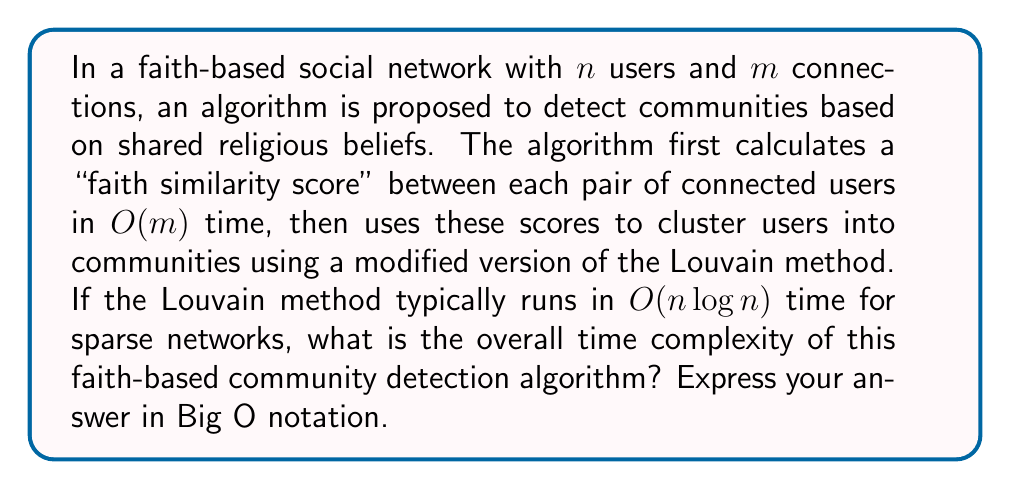Teach me how to tackle this problem. To analyze the time complexity of this algorithm, we need to consider its two main steps:

1. Calculating faith similarity scores:
   This step processes each connection in the network, which takes $O(m)$ time.

2. Clustering users with the modified Louvain method:
   The Louvain method typically runs in $O(n \log n)$ time for sparse networks.

To determine the overall time complexity, we need to add these two steps:

$O(m) + O(n \log n)$

In social networks, the number of connections $m$ is often proportional to the number of users $n$, especially in sparse networks. This relationship is typically expressed as $m = O(n)$.

Substituting this into our expression:

$O(n) + O(n \log n)$

Now, we need to simplify this expression. In Big O notation, we only keep the term that grows the fastest as $n$ increases. Between $O(n)$ and $O(n \log n)$, the latter grows faster.

Therefore, the overall time complexity simplifies to $O(n \log n)$.

This analysis shows that the faith-based community detection algorithm has a relatively efficient time complexity, scaling slightly superlinearly with the number of users in the network. However, as a Christian librarian, it's important to consider the ethical implications of using such algorithms to categorize individuals based on their faith, and to be cautious about potential misuse or oversimplification of complex spiritual matters.
Answer: $O(n \log n)$ 